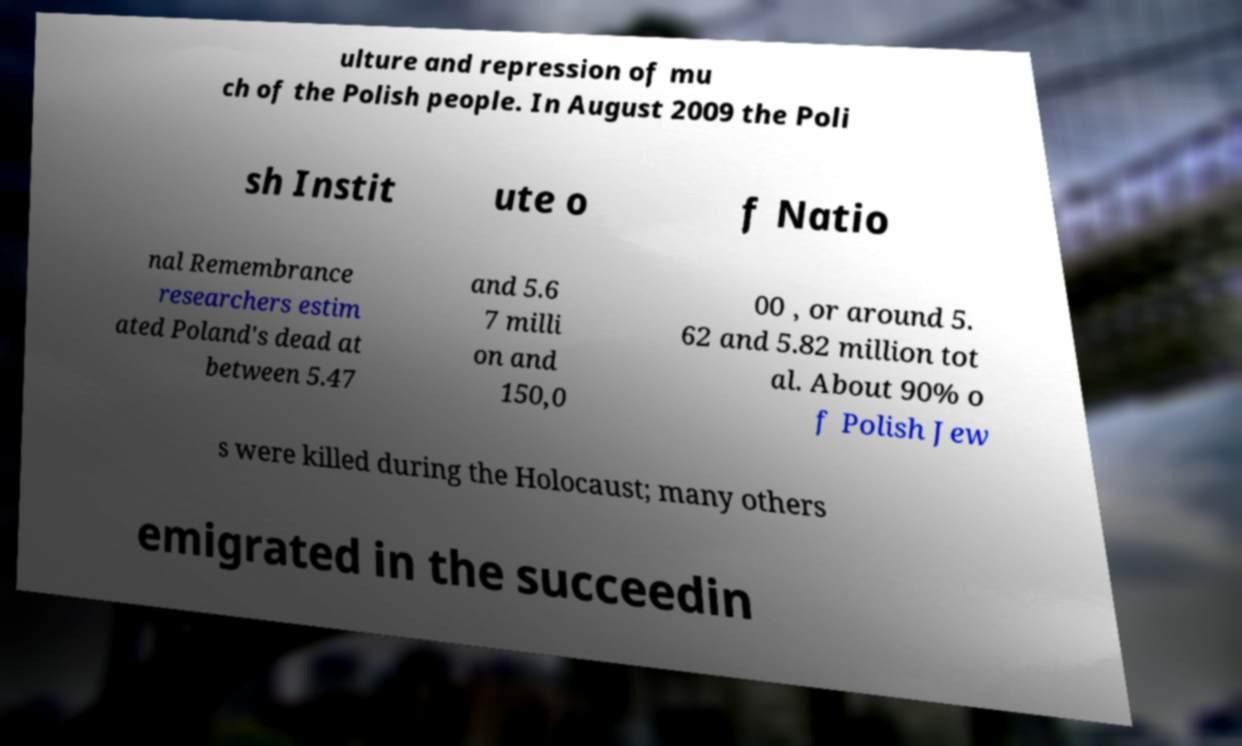Can you read and provide the text displayed in the image?This photo seems to have some interesting text. Can you extract and type it out for me? ulture and repression of mu ch of the Polish people. In August 2009 the Poli sh Instit ute o f Natio nal Remembrance researchers estim ated Poland's dead at between 5.47 and 5.6 7 milli on and 150,0 00 , or around 5. 62 and 5.82 million tot al. About 90% o f Polish Jew s were killed during the Holocaust; many others emigrated in the succeedin 